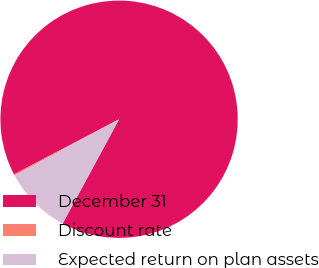<chart> <loc_0><loc_0><loc_500><loc_500><pie_chart><fcel>December 31<fcel>Discount rate<fcel>Expected return on plan assets<nl><fcel>90.58%<fcel>0.19%<fcel>9.23%<nl></chart> 